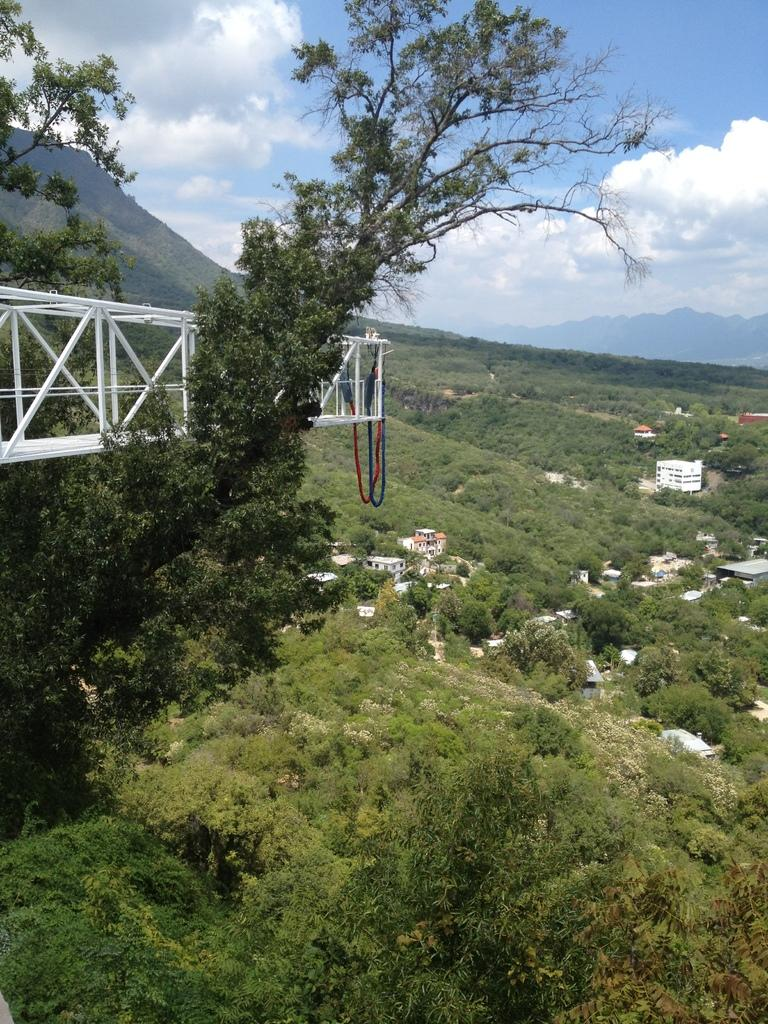What type of vegetation can be seen in the image? There are trees in the image. What structures are visible in the background of the image? There are buildings in the background of the image. What material is used for the rods on the left side of the image? The rods on the left side of the image are made of metal. What is visible at the top of the image? The sky is visible at the top of the image. How many chickens are present in the image? There are no chickens present in the image. What is the quiet process that is taking place in the image? There is no quiet process taking place in the image; the provided facts do not mention any processes or activities. 